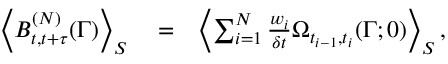<formula> <loc_0><loc_0><loc_500><loc_500>\begin{array} { r l r } { \left < B _ { t , t + \tau } ^ { ( N ) } ( \Gamma ) \right > _ { S } } & = } & { \left < \sum _ { i = 1 } ^ { N } \frac { w _ { i } } { \delta t } \Omega _ { t _ { i - 1 } , t _ { i } } ( \Gamma ; 0 ) \right > _ { S } , } \end{array}</formula> 